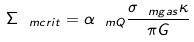<formula> <loc_0><loc_0><loc_500><loc_500>\Sigma _ { \ m { c r i t } } = \alpha _ { \ m { Q } } \frac { \sigma _ { \ m { g a s } } \kappa } { \pi G }</formula> 